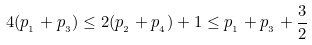Convert formula to latex. <formula><loc_0><loc_0><loc_500><loc_500>4 ( p _ { _ { 1 } } + p _ { _ { 3 } } ) \leq 2 ( p _ { _ { 2 } } + p _ { _ { 4 } } ) + 1 \leq p _ { _ { 1 } } + p _ { _ { 3 } } + \frac { 3 } { 2 }</formula> 